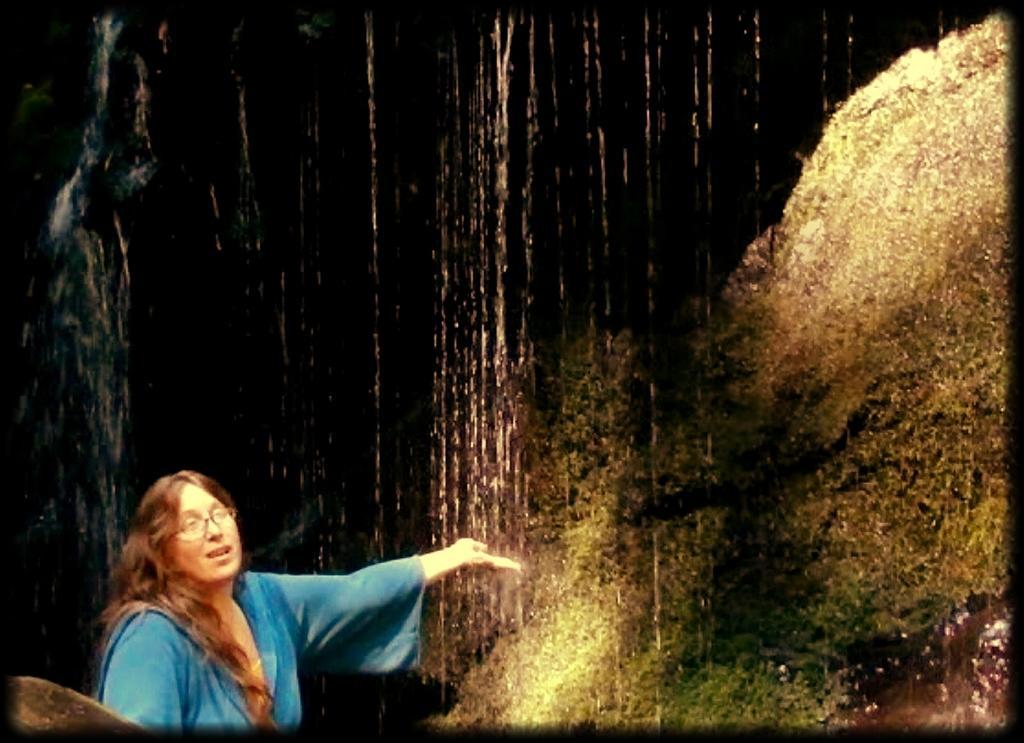Can you describe this image briefly? In the image there is a woman in blue dress standing in front of waterfall. 